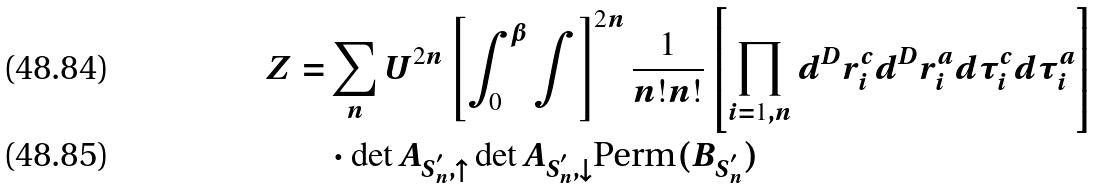Convert formula to latex. <formula><loc_0><loc_0><loc_500><loc_500>Z = & \sum _ { n } U ^ { 2 n } \left [ \int _ { 0 } ^ { \beta } \int \right ] ^ { 2 n } \frac { 1 } { n ! n ! } \left [ \prod _ { i = 1 , n } d ^ { D } r ^ { c } _ { i } d ^ { D } r ^ { a } _ { i } d \tau ^ { c } _ { i } d \tau ^ { a } _ { i } \right ] \\ & \cdot \det A _ { { S } _ { n } ^ { ^ { \prime } } , \uparrow } \det A _ { { S } _ { n } ^ { ^ { \prime } } , \downarrow } \text {Perm} ( B _ { { S } _ { n } ^ { ^ { \prime } } } )</formula> 